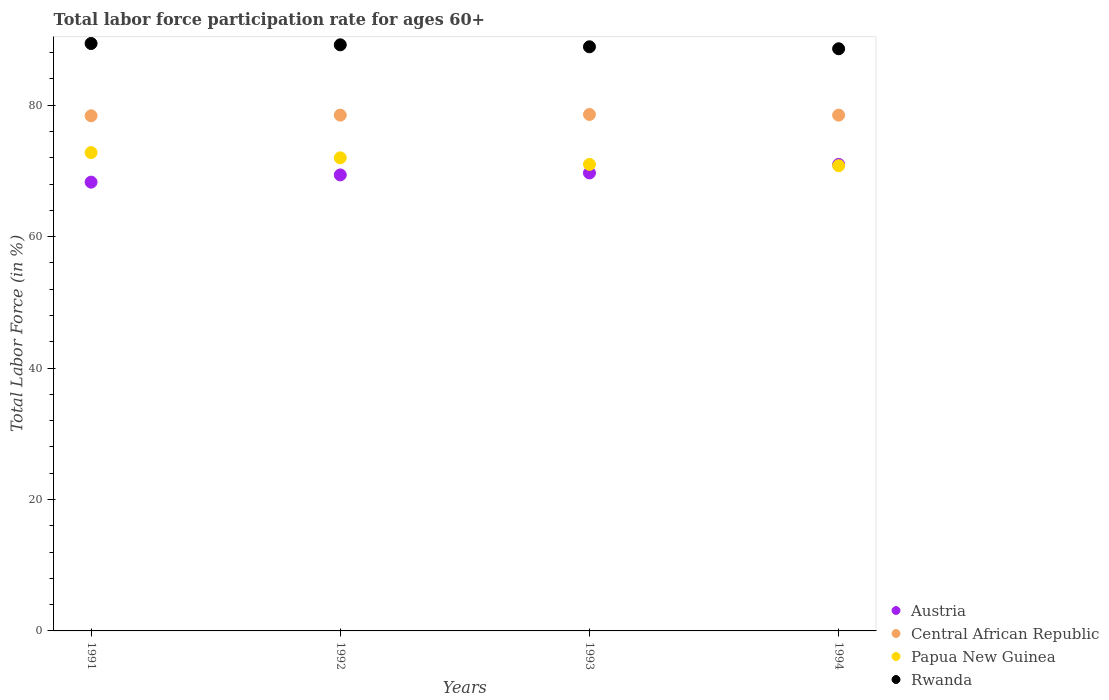How many different coloured dotlines are there?
Give a very brief answer. 4. What is the labor force participation rate in Central African Republic in 1991?
Offer a very short reply. 78.4. Across all years, what is the maximum labor force participation rate in Central African Republic?
Your answer should be compact. 78.6. Across all years, what is the minimum labor force participation rate in Papua New Guinea?
Ensure brevity in your answer.  70.8. In which year was the labor force participation rate in Austria maximum?
Ensure brevity in your answer.  1994. In which year was the labor force participation rate in Rwanda minimum?
Provide a succinct answer. 1994. What is the total labor force participation rate in Austria in the graph?
Your answer should be compact. 278.4. What is the difference between the labor force participation rate in Central African Republic in 1991 and that in 1992?
Keep it short and to the point. -0.1. What is the difference between the labor force participation rate in Austria in 1991 and the labor force participation rate in Central African Republic in 1992?
Your answer should be compact. -10.2. What is the average labor force participation rate in Rwanda per year?
Provide a short and direct response. 89.02. In the year 1994, what is the difference between the labor force participation rate in Papua New Guinea and labor force participation rate in Rwanda?
Provide a succinct answer. -17.8. In how many years, is the labor force participation rate in Austria greater than 12 %?
Provide a short and direct response. 4. What is the ratio of the labor force participation rate in Austria in 1991 to that in 1993?
Your answer should be very brief. 0.98. Is the difference between the labor force participation rate in Papua New Guinea in 1991 and 1993 greater than the difference between the labor force participation rate in Rwanda in 1991 and 1993?
Keep it short and to the point. Yes. What is the difference between the highest and the second highest labor force participation rate in Austria?
Give a very brief answer. 1.3. What is the difference between the highest and the lowest labor force participation rate in Central African Republic?
Offer a terse response. 0.2. In how many years, is the labor force participation rate in Papua New Guinea greater than the average labor force participation rate in Papua New Guinea taken over all years?
Keep it short and to the point. 2. Is it the case that in every year, the sum of the labor force participation rate in Central African Republic and labor force participation rate in Rwanda  is greater than the sum of labor force participation rate in Papua New Guinea and labor force participation rate in Austria?
Provide a succinct answer. No. How many years are there in the graph?
Offer a terse response. 4. What is the difference between two consecutive major ticks on the Y-axis?
Keep it short and to the point. 20. Does the graph contain grids?
Your answer should be very brief. No. How are the legend labels stacked?
Offer a terse response. Vertical. What is the title of the graph?
Give a very brief answer. Total labor force participation rate for ages 60+. Does "Other small states" appear as one of the legend labels in the graph?
Your response must be concise. No. What is the label or title of the X-axis?
Give a very brief answer. Years. What is the Total Labor Force (in %) of Austria in 1991?
Ensure brevity in your answer.  68.3. What is the Total Labor Force (in %) of Central African Republic in 1991?
Ensure brevity in your answer.  78.4. What is the Total Labor Force (in %) of Papua New Guinea in 1991?
Give a very brief answer. 72.8. What is the Total Labor Force (in %) of Rwanda in 1991?
Offer a terse response. 89.4. What is the Total Labor Force (in %) in Austria in 1992?
Offer a terse response. 69.4. What is the Total Labor Force (in %) in Central African Republic in 1992?
Provide a short and direct response. 78.5. What is the Total Labor Force (in %) in Papua New Guinea in 1992?
Offer a very short reply. 72. What is the Total Labor Force (in %) in Rwanda in 1992?
Your answer should be compact. 89.2. What is the Total Labor Force (in %) of Austria in 1993?
Your answer should be compact. 69.7. What is the Total Labor Force (in %) in Central African Republic in 1993?
Your answer should be very brief. 78.6. What is the Total Labor Force (in %) of Rwanda in 1993?
Provide a short and direct response. 88.9. What is the Total Labor Force (in %) in Austria in 1994?
Keep it short and to the point. 71. What is the Total Labor Force (in %) in Central African Republic in 1994?
Keep it short and to the point. 78.5. What is the Total Labor Force (in %) in Papua New Guinea in 1994?
Your answer should be compact. 70.8. What is the Total Labor Force (in %) of Rwanda in 1994?
Your response must be concise. 88.6. Across all years, what is the maximum Total Labor Force (in %) in Central African Republic?
Offer a terse response. 78.6. Across all years, what is the maximum Total Labor Force (in %) in Papua New Guinea?
Make the answer very short. 72.8. Across all years, what is the maximum Total Labor Force (in %) of Rwanda?
Your answer should be very brief. 89.4. Across all years, what is the minimum Total Labor Force (in %) of Austria?
Offer a very short reply. 68.3. Across all years, what is the minimum Total Labor Force (in %) of Central African Republic?
Your answer should be compact. 78.4. Across all years, what is the minimum Total Labor Force (in %) of Papua New Guinea?
Make the answer very short. 70.8. Across all years, what is the minimum Total Labor Force (in %) in Rwanda?
Make the answer very short. 88.6. What is the total Total Labor Force (in %) in Austria in the graph?
Provide a short and direct response. 278.4. What is the total Total Labor Force (in %) in Central African Republic in the graph?
Provide a succinct answer. 314. What is the total Total Labor Force (in %) in Papua New Guinea in the graph?
Provide a short and direct response. 286.6. What is the total Total Labor Force (in %) of Rwanda in the graph?
Offer a very short reply. 356.1. What is the difference between the Total Labor Force (in %) of Austria in 1991 and that in 1992?
Offer a very short reply. -1.1. What is the difference between the Total Labor Force (in %) in Central African Republic in 1991 and that in 1992?
Make the answer very short. -0.1. What is the difference between the Total Labor Force (in %) of Rwanda in 1991 and that in 1992?
Your response must be concise. 0.2. What is the difference between the Total Labor Force (in %) in Austria in 1991 and that in 1993?
Ensure brevity in your answer.  -1.4. What is the difference between the Total Labor Force (in %) in Central African Republic in 1991 and that in 1993?
Your answer should be compact. -0.2. What is the difference between the Total Labor Force (in %) of Papua New Guinea in 1991 and that in 1993?
Your answer should be very brief. 1.8. What is the difference between the Total Labor Force (in %) of Rwanda in 1991 and that in 1993?
Your answer should be compact. 0.5. What is the difference between the Total Labor Force (in %) in Papua New Guinea in 1991 and that in 1994?
Offer a terse response. 2. What is the difference between the Total Labor Force (in %) of Rwanda in 1991 and that in 1994?
Offer a terse response. 0.8. What is the difference between the Total Labor Force (in %) in Austria in 1992 and that in 1993?
Ensure brevity in your answer.  -0.3. What is the difference between the Total Labor Force (in %) of Austria in 1992 and that in 1994?
Give a very brief answer. -1.6. What is the difference between the Total Labor Force (in %) in Central African Republic in 1992 and that in 1994?
Keep it short and to the point. 0. What is the difference between the Total Labor Force (in %) of Austria in 1993 and that in 1994?
Offer a very short reply. -1.3. What is the difference between the Total Labor Force (in %) of Rwanda in 1993 and that in 1994?
Keep it short and to the point. 0.3. What is the difference between the Total Labor Force (in %) in Austria in 1991 and the Total Labor Force (in %) in Central African Republic in 1992?
Give a very brief answer. -10.2. What is the difference between the Total Labor Force (in %) of Austria in 1991 and the Total Labor Force (in %) of Papua New Guinea in 1992?
Make the answer very short. -3.7. What is the difference between the Total Labor Force (in %) of Austria in 1991 and the Total Labor Force (in %) of Rwanda in 1992?
Give a very brief answer. -20.9. What is the difference between the Total Labor Force (in %) in Central African Republic in 1991 and the Total Labor Force (in %) in Papua New Guinea in 1992?
Ensure brevity in your answer.  6.4. What is the difference between the Total Labor Force (in %) of Papua New Guinea in 1991 and the Total Labor Force (in %) of Rwanda in 1992?
Keep it short and to the point. -16.4. What is the difference between the Total Labor Force (in %) in Austria in 1991 and the Total Labor Force (in %) in Central African Republic in 1993?
Provide a succinct answer. -10.3. What is the difference between the Total Labor Force (in %) of Austria in 1991 and the Total Labor Force (in %) of Rwanda in 1993?
Ensure brevity in your answer.  -20.6. What is the difference between the Total Labor Force (in %) of Papua New Guinea in 1991 and the Total Labor Force (in %) of Rwanda in 1993?
Your answer should be compact. -16.1. What is the difference between the Total Labor Force (in %) in Austria in 1991 and the Total Labor Force (in %) in Central African Republic in 1994?
Give a very brief answer. -10.2. What is the difference between the Total Labor Force (in %) in Austria in 1991 and the Total Labor Force (in %) in Rwanda in 1994?
Make the answer very short. -20.3. What is the difference between the Total Labor Force (in %) of Central African Republic in 1991 and the Total Labor Force (in %) of Rwanda in 1994?
Your answer should be very brief. -10.2. What is the difference between the Total Labor Force (in %) in Papua New Guinea in 1991 and the Total Labor Force (in %) in Rwanda in 1994?
Your response must be concise. -15.8. What is the difference between the Total Labor Force (in %) in Austria in 1992 and the Total Labor Force (in %) in Rwanda in 1993?
Offer a terse response. -19.5. What is the difference between the Total Labor Force (in %) of Papua New Guinea in 1992 and the Total Labor Force (in %) of Rwanda in 1993?
Provide a short and direct response. -16.9. What is the difference between the Total Labor Force (in %) in Austria in 1992 and the Total Labor Force (in %) in Papua New Guinea in 1994?
Offer a very short reply. -1.4. What is the difference between the Total Labor Force (in %) in Austria in 1992 and the Total Labor Force (in %) in Rwanda in 1994?
Your response must be concise. -19.2. What is the difference between the Total Labor Force (in %) of Central African Republic in 1992 and the Total Labor Force (in %) of Papua New Guinea in 1994?
Offer a very short reply. 7.7. What is the difference between the Total Labor Force (in %) in Central African Republic in 1992 and the Total Labor Force (in %) in Rwanda in 1994?
Your answer should be very brief. -10.1. What is the difference between the Total Labor Force (in %) in Papua New Guinea in 1992 and the Total Labor Force (in %) in Rwanda in 1994?
Your answer should be compact. -16.6. What is the difference between the Total Labor Force (in %) of Austria in 1993 and the Total Labor Force (in %) of Central African Republic in 1994?
Offer a terse response. -8.8. What is the difference between the Total Labor Force (in %) of Austria in 1993 and the Total Labor Force (in %) of Rwanda in 1994?
Offer a very short reply. -18.9. What is the difference between the Total Labor Force (in %) in Central African Republic in 1993 and the Total Labor Force (in %) in Papua New Guinea in 1994?
Provide a short and direct response. 7.8. What is the difference between the Total Labor Force (in %) in Papua New Guinea in 1993 and the Total Labor Force (in %) in Rwanda in 1994?
Provide a succinct answer. -17.6. What is the average Total Labor Force (in %) in Austria per year?
Make the answer very short. 69.6. What is the average Total Labor Force (in %) in Central African Republic per year?
Give a very brief answer. 78.5. What is the average Total Labor Force (in %) in Papua New Guinea per year?
Your answer should be compact. 71.65. What is the average Total Labor Force (in %) of Rwanda per year?
Give a very brief answer. 89.03. In the year 1991, what is the difference between the Total Labor Force (in %) of Austria and Total Labor Force (in %) of Rwanda?
Your answer should be very brief. -21.1. In the year 1991, what is the difference between the Total Labor Force (in %) in Central African Republic and Total Labor Force (in %) in Papua New Guinea?
Keep it short and to the point. 5.6. In the year 1991, what is the difference between the Total Labor Force (in %) of Papua New Guinea and Total Labor Force (in %) of Rwanda?
Your answer should be compact. -16.6. In the year 1992, what is the difference between the Total Labor Force (in %) in Austria and Total Labor Force (in %) in Rwanda?
Make the answer very short. -19.8. In the year 1992, what is the difference between the Total Labor Force (in %) in Central African Republic and Total Labor Force (in %) in Rwanda?
Keep it short and to the point. -10.7. In the year 1992, what is the difference between the Total Labor Force (in %) in Papua New Guinea and Total Labor Force (in %) in Rwanda?
Provide a short and direct response. -17.2. In the year 1993, what is the difference between the Total Labor Force (in %) of Austria and Total Labor Force (in %) of Rwanda?
Give a very brief answer. -19.2. In the year 1993, what is the difference between the Total Labor Force (in %) of Central African Republic and Total Labor Force (in %) of Papua New Guinea?
Offer a terse response. 7.6. In the year 1993, what is the difference between the Total Labor Force (in %) in Central African Republic and Total Labor Force (in %) in Rwanda?
Your response must be concise. -10.3. In the year 1993, what is the difference between the Total Labor Force (in %) of Papua New Guinea and Total Labor Force (in %) of Rwanda?
Offer a very short reply. -17.9. In the year 1994, what is the difference between the Total Labor Force (in %) of Austria and Total Labor Force (in %) of Central African Republic?
Your answer should be very brief. -7.5. In the year 1994, what is the difference between the Total Labor Force (in %) in Austria and Total Labor Force (in %) in Rwanda?
Ensure brevity in your answer.  -17.6. In the year 1994, what is the difference between the Total Labor Force (in %) of Central African Republic and Total Labor Force (in %) of Papua New Guinea?
Your response must be concise. 7.7. In the year 1994, what is the difference between the Total Labor Force (in %) in Central African Republic and Total Labor Force (in %) in Rwanda?
Provide a short and direct response. -10.1. In the year 1994, what is the difference between the Total Labor Force (in %) in Papua New Guinea and Total Labor Force (in %) in Rwanda?
Keep it short and to the point. -17.8. What is the ratio of the Total Labor Force (in %) in Austria in 1991 to that in 1992?
Give a very brief answer. 0.98. What is the ratio of the Total Labor Force (in %) in Central African Republic in 1991 to that in 1992?
Your response must be concise. 1. What is the ratio of the Total Labor Force (in %) of Papua New Guinea in 1991 to that in 1992?
Your answer should be compact. 1.01. What is the ratio of the Total Labor Force (in %) of Rwanda in 1991 to that in 1992?
Keep it short and to the point. 1. What is the ratio of the Total Labor Force (in %) of Austria in 1991 to that in 1993?
Provide a short and direct response. 0.98. What is the ratio of the Total Labor Force (in %) in Papua New Guinea in 1991 to that in 1993?
Ensure brevity in your answer.  1.03. What is the ratio of the Total Labor Force (in %) of Rwanda in 1991 to that in 1993?
Offer a very short reply. 1.01. What is the ratio of the Total Labor Force (in %) of Central African Republic in 1991 to that in 1994?
Offer a very short reply. 1. What is the ratio of the Total Labor Force (in %) of Papua New Guinea in 1991 to that in 1994?
Your response must be concise. 1.03. What is the ratio of the Total Labor Force (in %) in Rwanda in 1991 to that in 1994?
Offer a very short reply. 1.01. What is the ratio of the Total Labor Force (in %) in Central African Republic in 1992 to that in 1993?
Provide a short and direct response. 1. What is the ratio of the Total Labor Force (in %) in Papua New Guinea in 1992 to that in 1993?
Provide a short and direct response. 1.01. What is the ratio of the Total Labor Force (in %) of Austria in 1992 to that in 1994?
Ensure brevity in your answer.  0.98. What is the ratio of the Total Labor Force (in %) in Central African Republic in 1992 to that in 1994?
Ensure brevity in your answer.  1. What is the ratio of the Total Labor Force (in %) of Papua New Guinea in 1992 to that in 1994?
Make the answer very short. 1.02. What is the ratio of the Total Labor Force (in %) of Rwanda in 1992 to that in 1994?
Provide a short and direct response. 1.01. What is the ratio of the Total Labor Force (in %) in Austria in 1993 to that in 1994?
Keep it short and to the point. 0.98. What is the ratio of the Total Labor Force (in %) of Central African Republic in 1993 to that in 1994?
Your answer should be very brief. 1. What is the ratio of the Total Labor Force (in %) in Papua New Guinea in 1993 to that in 1994?
Make the answer very short. 1. What is the difference between the highest and the second highest Total Labor Force (in %) in Austria?
Ensure brevity in your answer.  1.3. What is the difference between the highest and the lowest Total Labor Force (in %) of Central African Republic?
Provide a short and direct response. 0.2. What is the difference between the highest and the lowest Total Labor Force (in %) in Papua New Guinea?
Give a very brief answer. 2. 